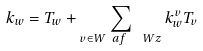Convert formula to latex. <formula><loc_0><loc_0><loc_500><loc_500>k _ { w } = T _ { w } + \sum _ { v \in W _ { \ } a f \ \ W z } k ^ { v } _ { w } T _ { v }</formula> 